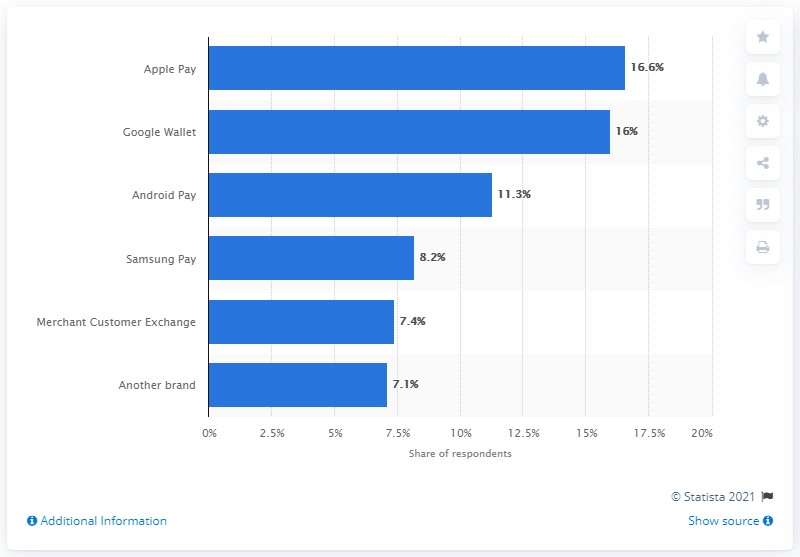Draw attention to some important aspects in this diagram. In the third quarter of 2016, 16.6 percent of SMBs used Apple Pay as their payment method. 